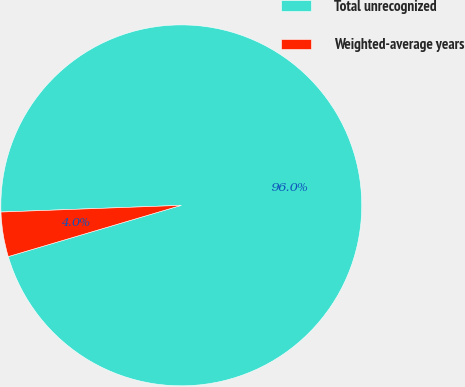Convert chart to OTSL. <chart><loc_0><loc_0><loc_500><loc_500><pie_chart><fcel>Total unrecognized<fcel>Weighted-average years<nl><fcel>96.01%<fcel>3.99%<nl></chart> 